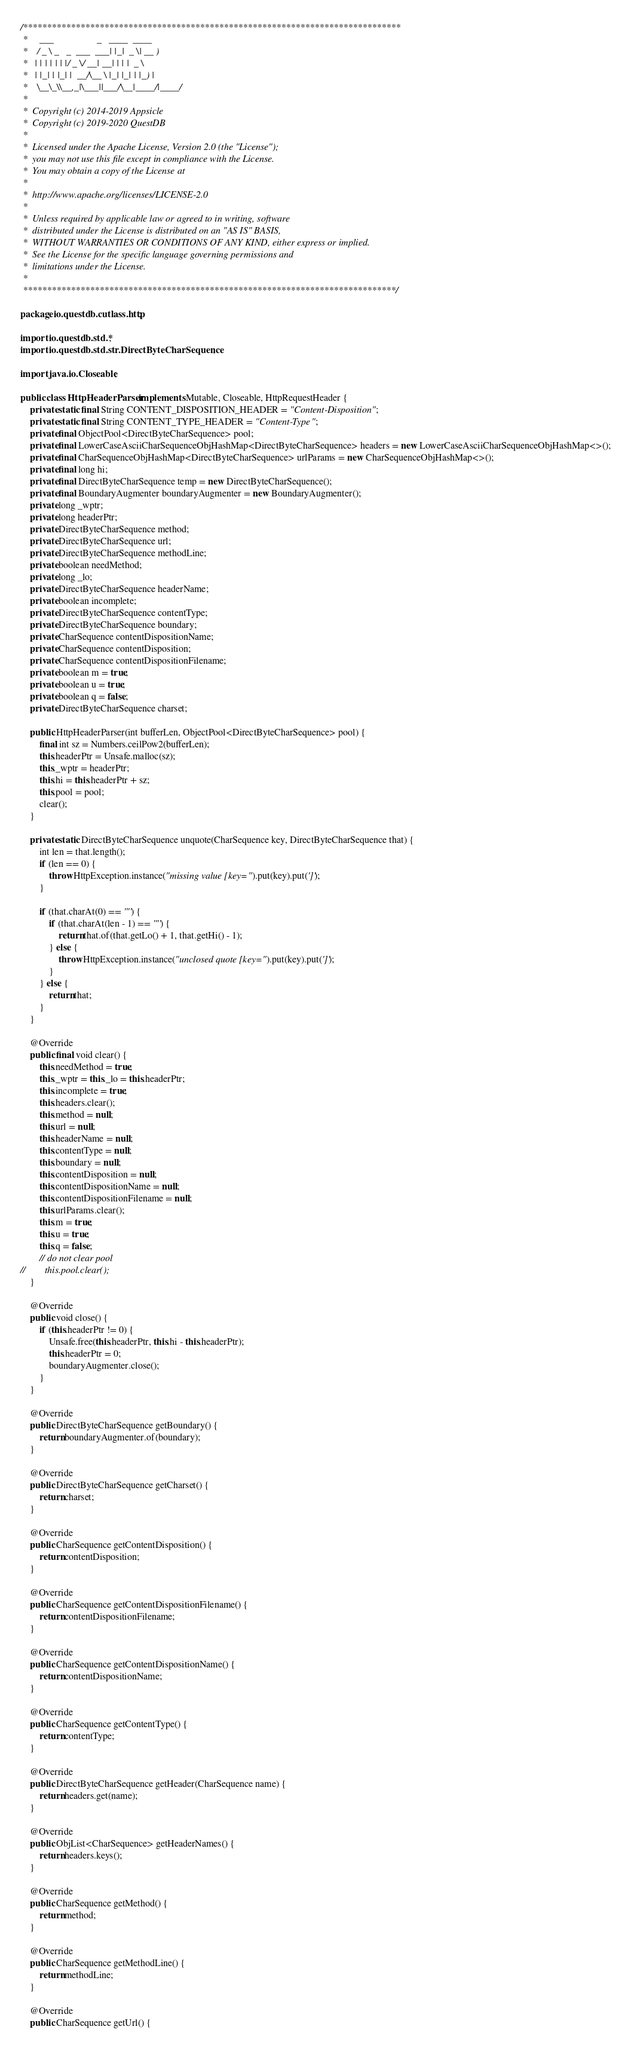Convert code to text. <code><loc_0><loc_0><loc_500><loc_500><_Java_>/*******************************************************************************
 *     ___                  _   ____  ____
 *    / _ \ _   _  ___  ___| |_|  _ \| __ )
 *   | | | | | | |/ _ \/ __| __| | | |  _ \
 *   | |_| | |_| |  __/\__ \ |_| |_| | |_) |
 *    \__\_\\__,_|\___||___/\__|____/|____/
 *
 *  Copyright (c) 2014-2019 Appsicle
 *  Copyright (c) 2019-2020 QuestDB
 *
 *  Licensed under the Apache License, Version 2.0 (the "License");
 *  you may not use this file except in compliance with the License.
 *  You may obtain a copy of the License at
 *
 *  http://www.apache.org/licenses/LICENSE-2.0
 *
 *  Unless required by applicable law or agreed to in writing, software
 *  distributed under the License is distributed on an "AS IS" BASIS,
 *  WITHOUT WARRANTIES OR CONDITIONS OF ANY KIND, either express or implied.
 *  See the License for the specific language governing permissions and
 *  limitations under the License.
 *
 ******************************************************************************/

package io.questdb.cutlass.http;

import io.questdb.std.*;
import io.questdb.std.str.DirectByteCharSequence;

import java.io.Closeable;

public class HttpHeaderParser implements Mutable, Closeable, HttpRequestHeader {
    private static final String CONTENT_DISPOSITION_HEADER = "Content-Disposition";
    private static final String CONTENT_TYPE_HEADER = "Content-Type";
    private final ObjectPool<DirectByteCharSequence> pool;
    private final LowerCaseAsciiCharSequenceObjHashMap<DirectByteCharSequence> headers = new LowerCaseAsciiCharSequenceObjHashMap<>();
    private final CharSequenceObjHashMap<DirectByteCharSequence> urlParams = new CharSequenceObjHashMap<>();
    private final long hi;
    private final DirectByteCharSequence temp = new DirectByteCharSequence();
    private final BoundaryAugmenter boundaryAugmenter = new BoundaryAugmenter();
    private long _wptr;
    private long headerPtr;
    private DirectByteCharSequence method;
    private DirectByteCharSequence url;
    private DirectByteCharSequence methodLine;
    private boolean needMethod;
    private long _lo;
    private DirectByteCharSequence headerName;
    private boolean incomplete;
    private DirectByteCharSequence contentType;
    private DirectByteCharSequence boundary;
    private CharSequence contentDispositionName;
    private CharSequence contentDisposition;
    private CharSequence contentDispositionFilename;
    private boolean m = true;
    private boolean u = true;
    private boolean q = false;
    private DirectByteCharSequence charset;

    public HttpHeaderParser(int bufferLen, ObjectPool<DirectByteCharSequence> pool) {
        final int sz = Numbers.ceilPow2(bufferLen);
        this.headerPtr = Unsafe.malloc(sz);
        this._wptr = headerPtr;
        this.hi = this.headerPtr + sz;
        this.pool = pool;
        clear();
    }

    private static DirectByteCharSequence unquote(CharSequence key, DirectByteCharSequence that) {
        int len = that.length();
        if (len == 0) {
            throw HttpException.instance("missing value [key=").put(key).put(']');
        }

        if (that.charAt(0) == '"') {
            if (that.charAt(len - 1) == '"') {
                return that.of(that.getLo() + 1, that.getHi() - 1);
            } else {
                throw HttpException.instance("unclosed quote [key=").put(key).put(']');
            }
        } else {
            return that;
        }
    }

    @Override
    public final void clear() {
        this.needMethod = true;
        this._wptr = this._lo = this.headerPtr;
        this.incomplete = true;
        this.headers.clear();
        this.method = null;
        this.url = null;
        this.headerName = null;
        this.contentType = null;
        this.boundary = null;
        this.contentDisposition = null;
        this.contentDispositionName = null;
        this.contentDispositionFilename = null;
        this.urlParams.clear();
        this.m = true;
        this.u = true;
        this.q = false;
        // do not clear pool
//        this.pool.clear();
    }

    @Override
    public void close() {
        if (this.headerPtr != 0) {
            Unsafe.free(this.headerPtr, this.hi - this.headerPtr);
            this.headerPtr = 0;
            boundaryAugmenter.close();
        }
    }

    @Override
    public DirectByteCharSequence getBoundary() {
        return boundaryAugmenter.of(boundary);
    }

    @Override
    public DirectByteCharSequence getCharset() {
        return charset;
    }

    @Override
    public CharSequence getContentDisposition() {
        return contentDisposition;
    }

    @Override
    public CharSequence getContentDispositionFilename() {
        return contentDispositionFilename;
    }

    @Override
    public CharSequence getContentDispositionName() {
        return contentDispositionName;
    }

    @Override
    public CharSequence getContentType() {
        return contentType;
    }

    @Override
    public DirectByteCharSequence getHeader(CharSequence name) {
        return headers.get(name);
    }

    @Override
    public ObjList<CharSequence> getHeaderNames() {
        return headers.keys();
    }

    @Override
    public CharSequence getMethod() {
        return method;
    }

    @Override
    public CharSequence getMethodLine() {
        return methodLine;
    }

    @Override
    public CharSequence getUrl() {</code> 